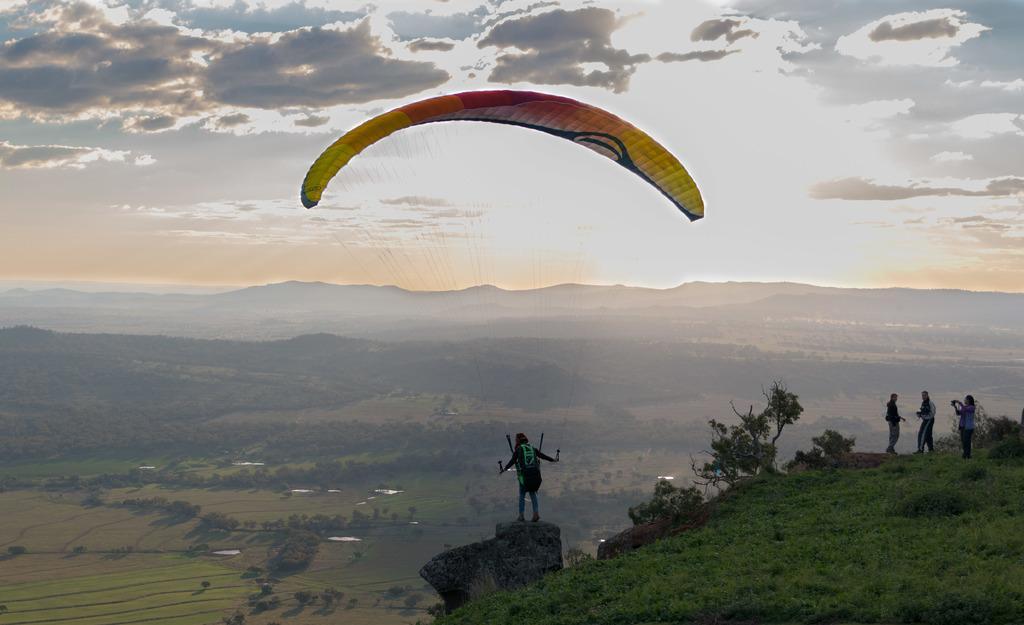Can you describe this image briefly? In this image we can see people, grass, plants, paragliding and hill. Background we can see cloudy sky. 